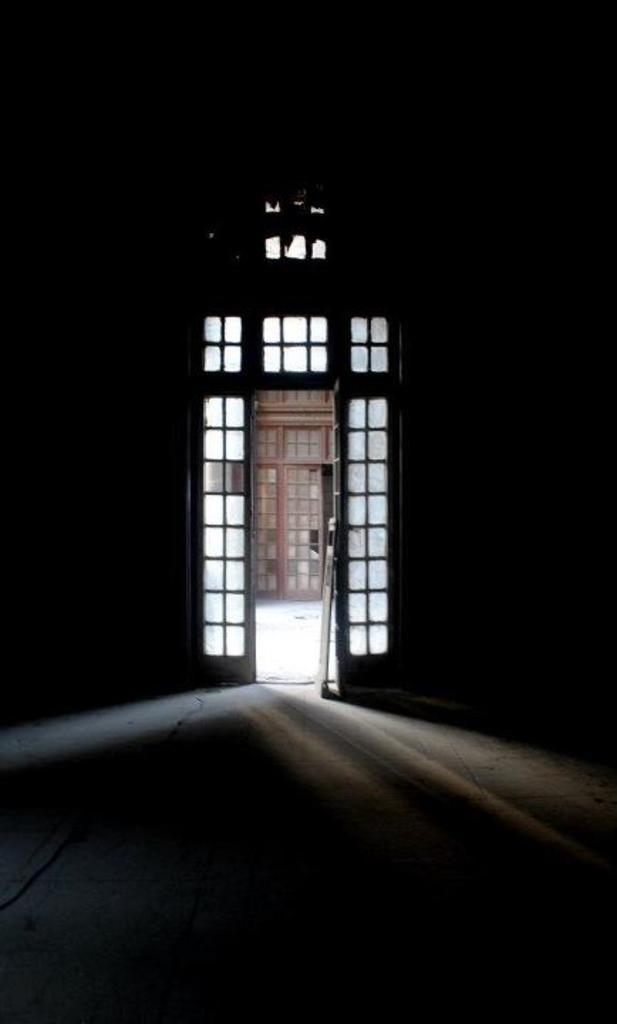What is the main subject of the image? The main subject of the image is a door entrance. Can you describe the interior of the door entrance? The interior of the door entrance is dark. What is located outside the door entrance? There is a door outside the entrance. What is the color of the door outside the entrance? The door outside the entrance is brown in color. What type of pin can be seen holding a poster on the door in the image? There is no pin or poster present on the door in the image. Is there a guitar leaning against the door in the image? There is no guitar present in the image. 